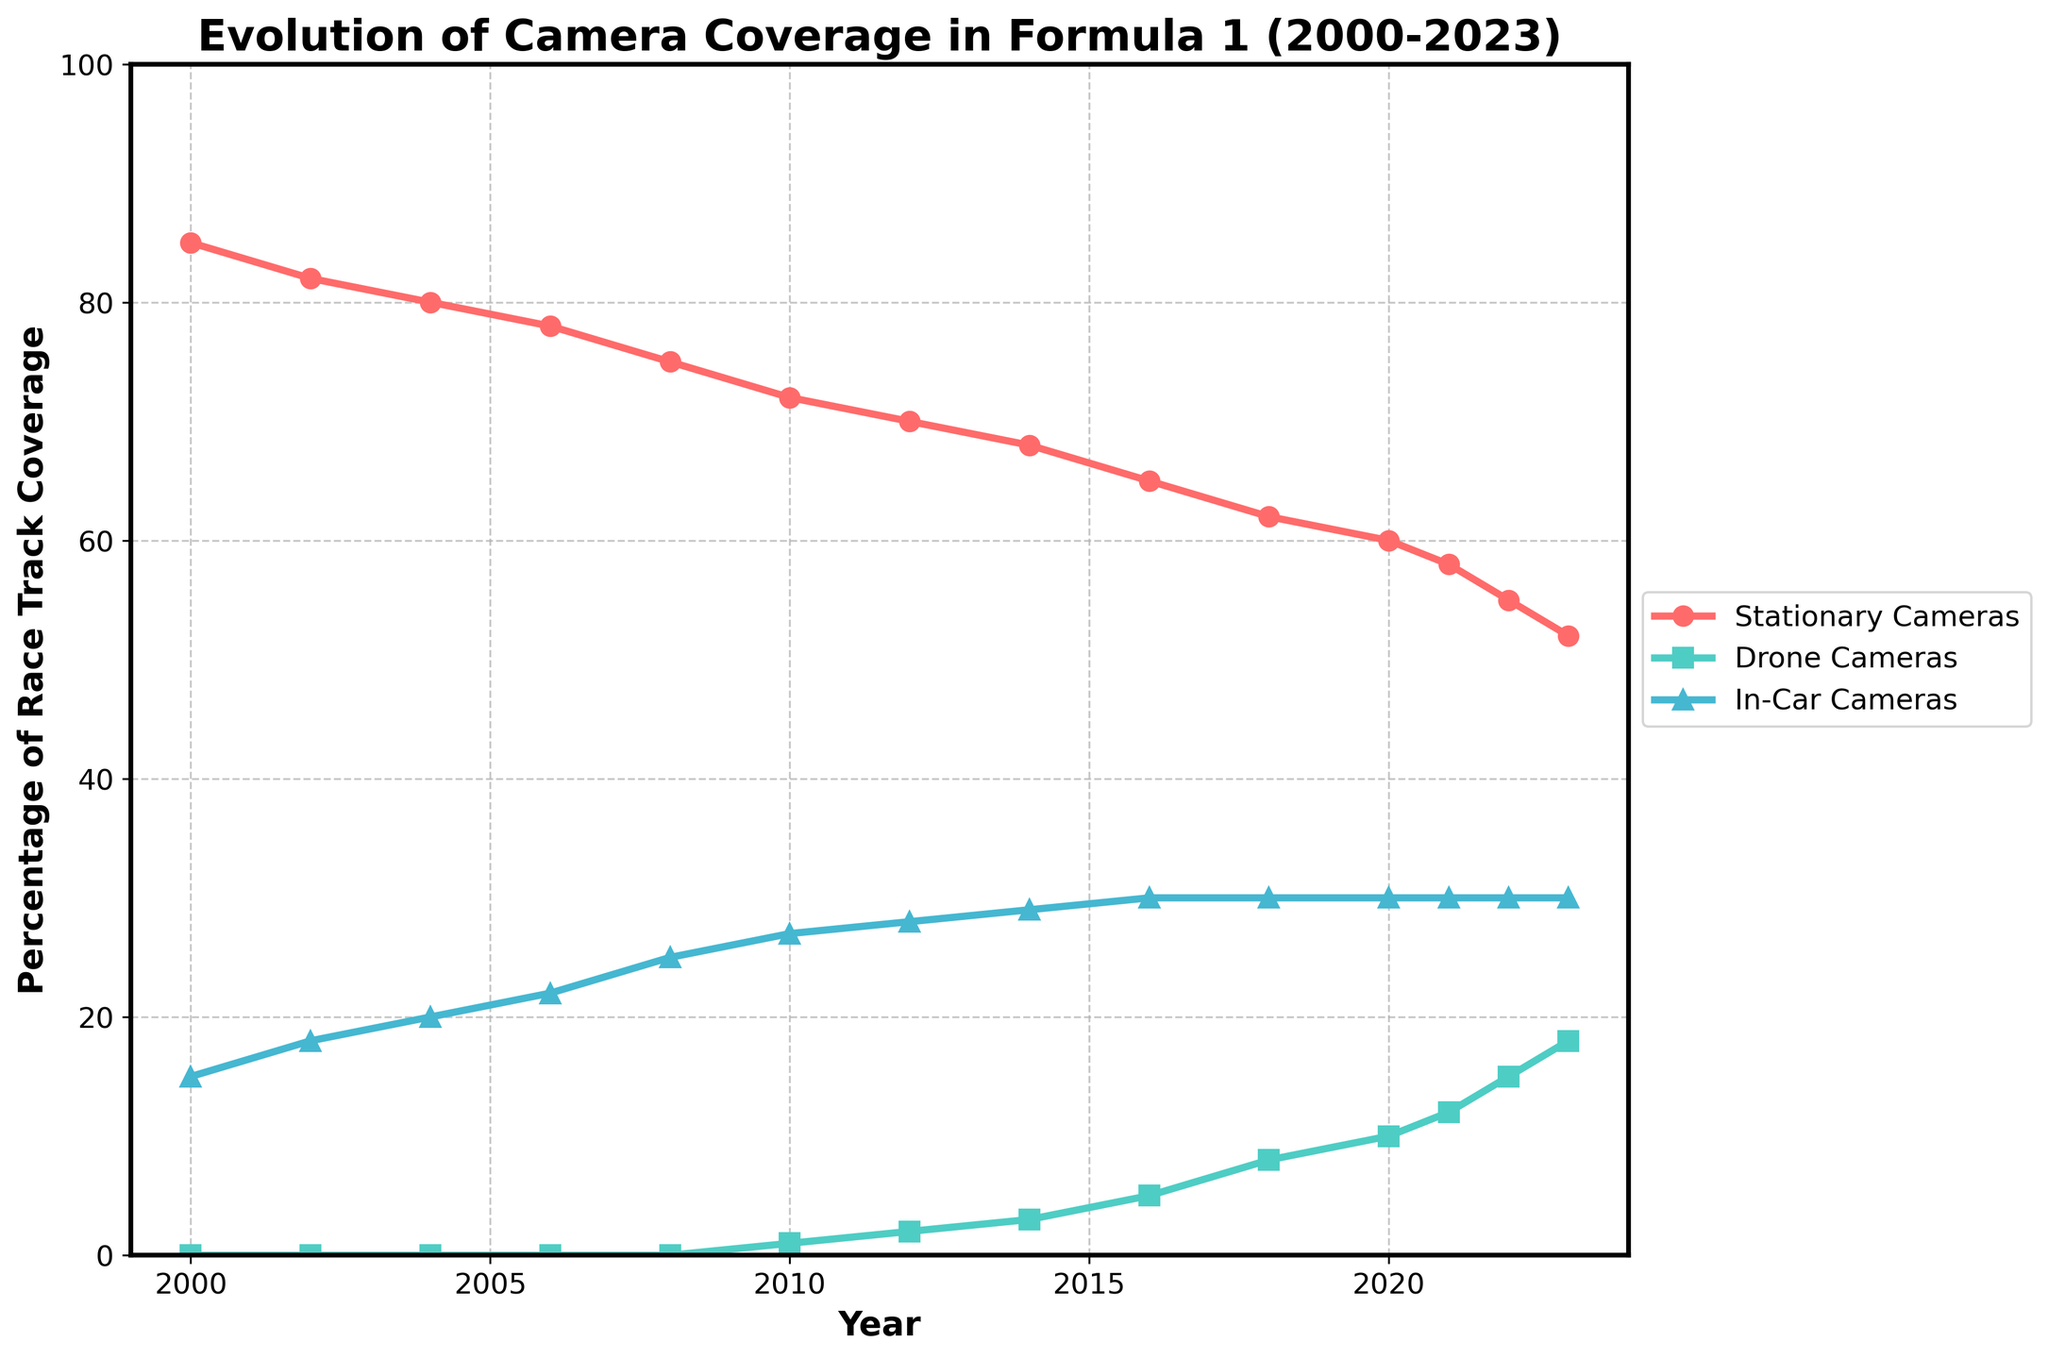What is the trend in the percentage of race track coverage by stationary cameras from 2000 to 2023? By observing the line representing stationary cameras, we see a decreasing trend. It starts at 85% in 2000 and drops to 52% by 2023.
Answer: Decreasing In which year did drone cameras first start to cover the race track, and what was their coverage percentage that year? The line for drone cameras starts from 0% and first shows coverage in 2010, with a percentage of 1%.
Answer: 2010, 1% What is the difference in the percentage of race track coverage between stationary and in-car cameras in 2023? In 2023, the percentage for stationary cameras is 52%, and for in-car cameras, it is 30%. The difference is 52% - 30% = 22%.
Answer: 22% Compare the coverage of drone cameras in 2014 and 2018. Which year had higher coverage and by how much? In 2014, the coverage by drone cameras is 3%, whereas in 2018, it is 8%. Thus, 2018 had higher coverage by 8% - 3% = 5%.
Answer: 2018, 5% What is the average percentage of race track coverage by in-car cameras from 2010 to 2023? The percentage of coverage by in-car cameras from 2010 to 2023 remains constant at 30% every year. So, the average is simply 30%.
Answer: 30% By how much did the coverage by stationary cameras decrease from 2000 to 2018? In 2000, stationary cameras covered 85% of the race track, and in 2018, it covered 62%. The decrease is 85% - 62% = 23%.
Answer: 23% What is the percentage of race track coverage by in-car cameras compared to drone cameras in 2020? In 2020, in-car cameras cover 30% and drone cameras cover 10%. The in-car coverage is 30%/10% = 3 times more than drone coverage.
Answer: 3 times Which type of camera had the highest increase in percentage coverage from 2010 to 2023? From 2010 to 2023, stationary cameras decreased, in-car cameras stayed the same (30%), and drone cameras increased from 1% to 18% (17 percentage points). Therefore, drone cameras saw the highest increase.
Answer: Drone cameras What is the combined percentage of race track coverage by all camera types in the years 2000 and 2023, respectively? In 2000, the combined coverage is 85% (Stationary) + 0% (Drone) + 15% (In-Car) = 100%. In 2023, it is 52% (Stationary) + 18% (Drone) + 30% (In-Car) = 100%.
Answer: 100%, 100% 